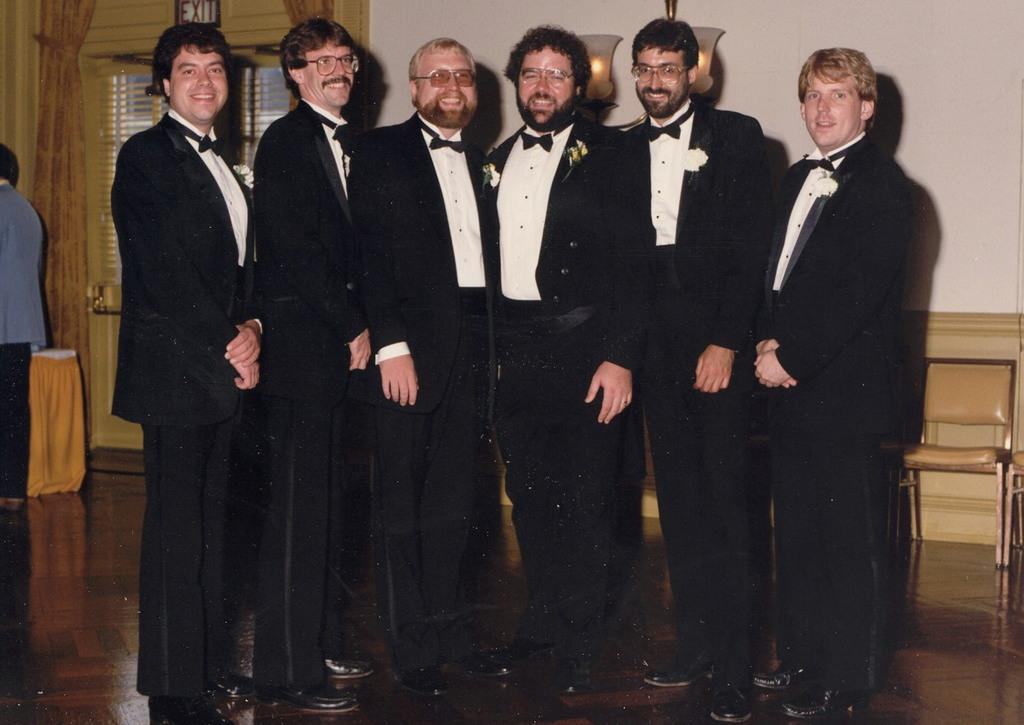What can be seen in the image? There are men standing in the image. Where are the men standing? The men are standing on the floor. What can be seen in the background of the image? There is a chandelier, chairs, tables, curtains, and a wall in the background of the image. What type of bone is being used as a decoration on the chandelier in the image? There is no bone present on the chandelier in the image. What type of produce can be seen on the tables in the image? There is no produce visible on the tables in the image. 